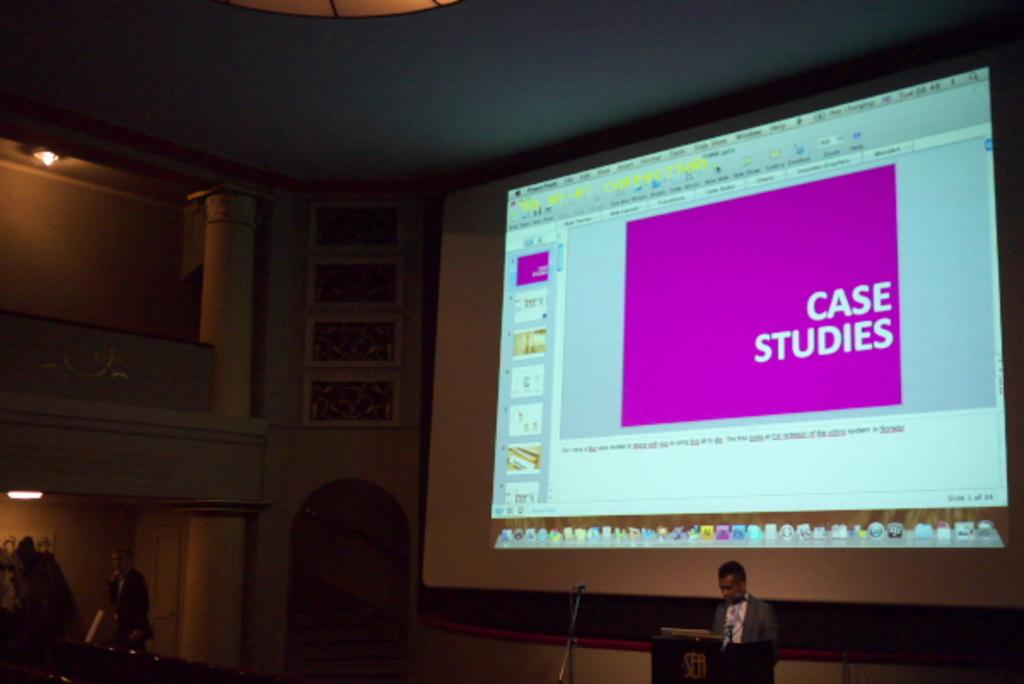<image>
Relay a brief, clear account of the picture shown. A computer monitor with the words Case Studies shown on the screen. 